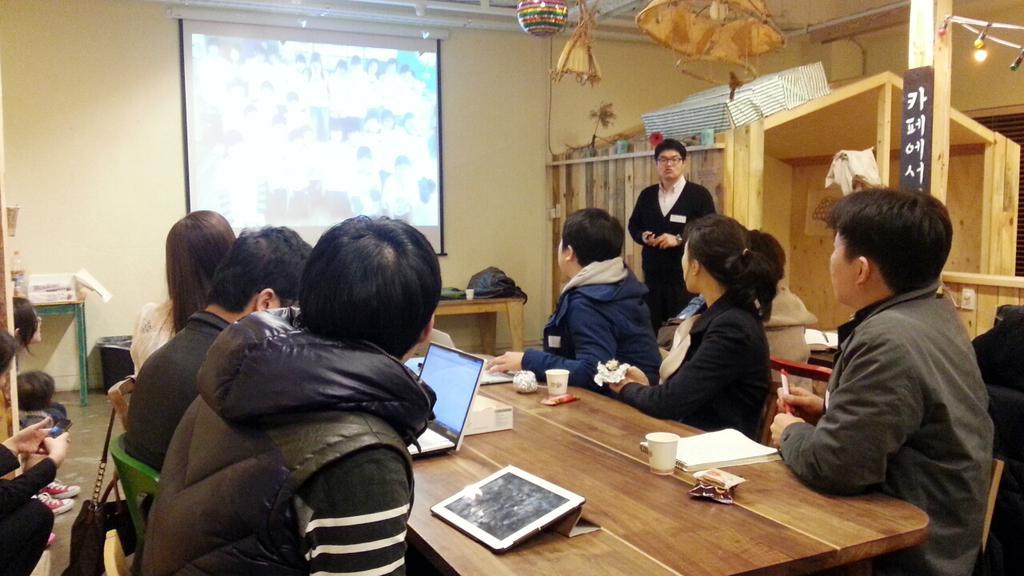Can you describe this image briefly? This picture is taken inside a room. There are people sitting on chairs at the table. They all are looking to the projector board hanging on the wall. On the table there is a tabletoid, a laptop, box, glasses, book and wrappers. To the left corner of the image there is another table and on it there is a bottle and box. There are decorative things hanging to the ceiling. To the right corner of the image there is a house and a pillar. In the background there is wall. 